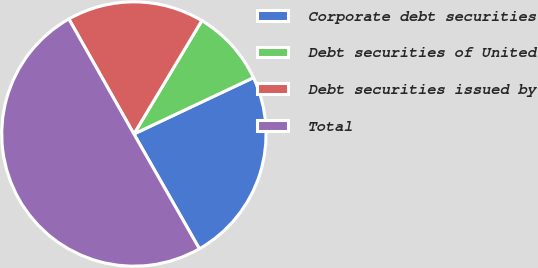Convert chart. <chart><loc_0><loc_0><loc_500><loc_500><pie_chart><fcel>Corporate debt securities<fcel>Debt securities of United<fcel>Debt securities issued by<fcel>Total<nl><fcel>23.76%<fcel>9.4%<fcel>16.78%<fcel>50.06%<nl></chart> 